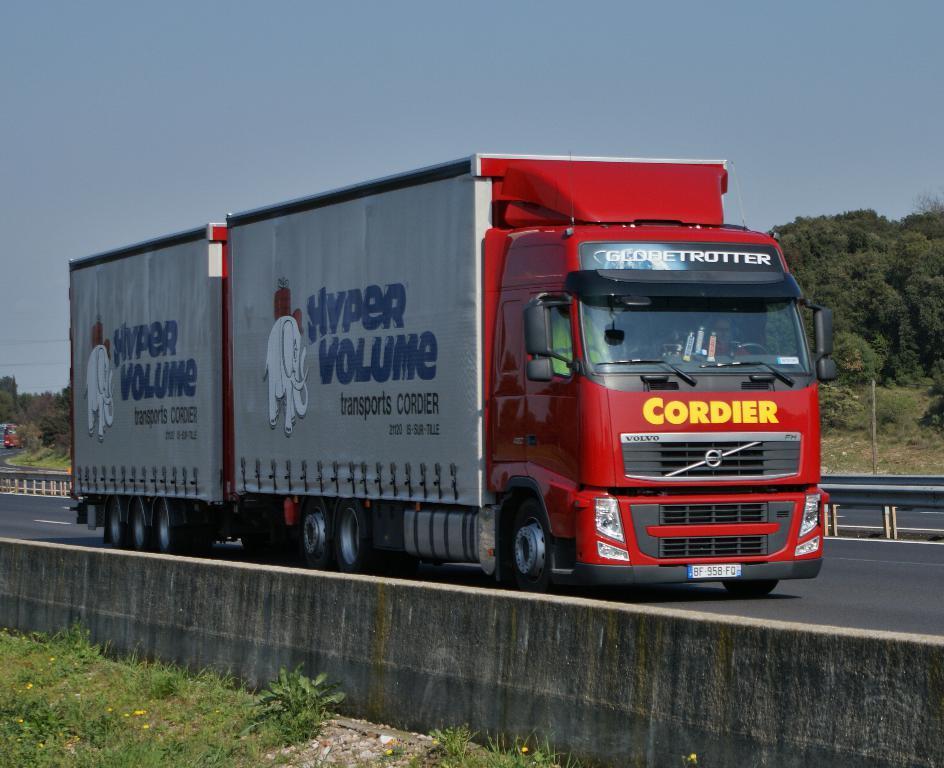Please provide a concise description of this image. In this image we can see few vehicles. There is some text and a logo on the container of the vehicle. There are many trees and plants in the image. There is a grassy land in the image. There is a road in the image. There is the sky in the image. There are road safety barriers in the image. 